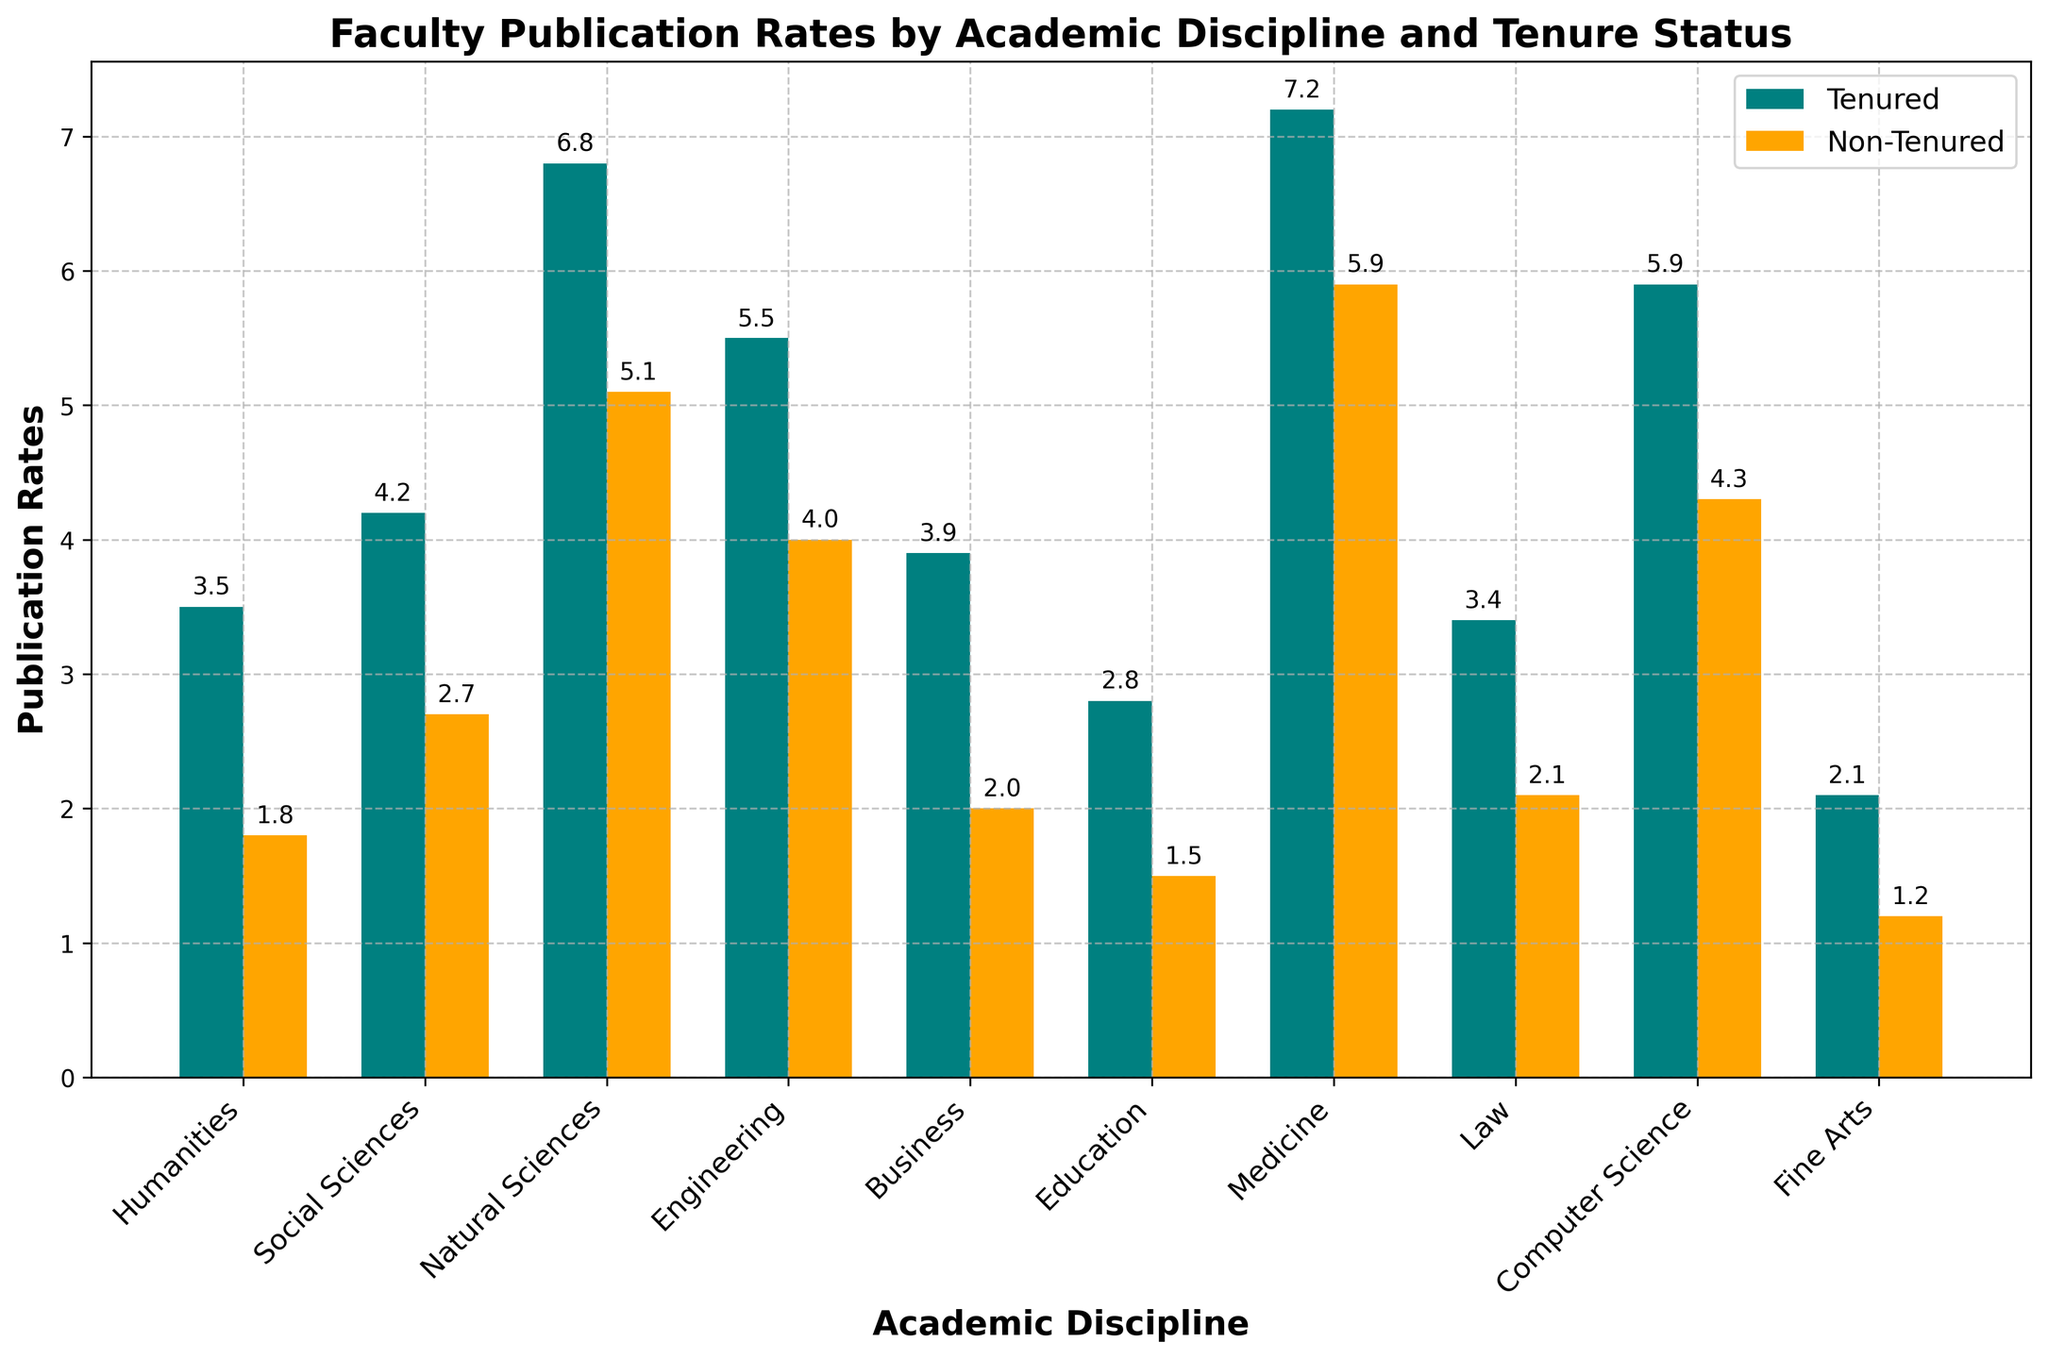What's the average publication rate for tenured faculty across all disciplines? To find the average, sum up the tenured publication rates for all disciplines and divide by the number of disciplines. The total sum is 3.5 + 4.2 + 6.8 + 5.5 + 3.9 + 2.8 + 7.2 + 3.4 + 5.9 + 2.1 = 45.3. There are 10 disciplines, so the average is 45.3 / 10 = 4.53
Answer: 4.53 Which discipline has the highest discrepancy between tenured and non-tenured publication rates? To find the highest discrepancy, calculate the difference between tenured and non-tenured publication rates for each discipline and identify the largest gap. The discrepancies are as follows: Humanities (1.7), Social Sciences (1.5), Natural Sciences (1.7), Engineering (1.5), Business (1.9), Education (1.3), Medicine (1.3), Law (1.3), Computer Science (1.6), Fine Arts (0.9). The highest discrepancy is in Business at 1.9
Answer: Business Are the publication rates of tenured faculty in Medicine higher than those in Computer Science? Compare the heights of the bars for tenured faculty in Medicine and Computer Science. Medicine has a rate of 7.2, while Computer Science has a rate of 5.9. Since 7.2 is greater than 5.9, the publication rates in Medicine are higher
Answer: Yes Which discipline has the lowest publication rate among non-tenured faculty? Compare the heights of the orange bars (non-tenured) across all disciplines. Fine Arts has the lowest publication rate at 1.2
Answer: Fine Arts What is the difference in publication rates between tenured and non-tenured faculty in the Natural Sciences? The publication rate for tenured faculty in Natural Sciences is 6.8 while for non-tenured faculty it is 5.1. The difference is 6.8 - 5.1 = 1.7
Answer: 1.7 What is the combined publication rate for tenured faculty in Engineering and Business? Add the publication rates for tenured faculty in Engineering (5.5) and Business (3.9). The combined rate is 5.5 + 3.9 = 9.4
Answer: 9.4 Is the publication rate of non-tenured faculty in Social Sciences greater than that in Business? Compare the heights of the orange bars for non-tenured faculty in Social Sciences and Business. Social Sciences have a rate of 2.7, and Business has a rate of 2.0. Since 2.7 is greater than 2.0, the rate in Social Sciences is higher
Answer: Yes What's the total sum of publication rates for non-tenured faculty across all disciplines? Sum up the non-tenured publication rates for all disciplines. The total is 1.8 + 2.7 + 5.1 + 4.0 + 2.0 + 1.5 + 5.9 + 2.1 + 4.3 + 1.2 = 30.6
Answer: 30.6 What is the average publication rate for non-tenured faculty in the Medicine and Humanities disciplines? Calculate the average of non-tenured rates for Medicine (5.9) and Humanities (1.8). The sum is 5.9 + 1.8 = 7.7, and the average is 7.7 / 2 = 3.85
Answer: 3.85 